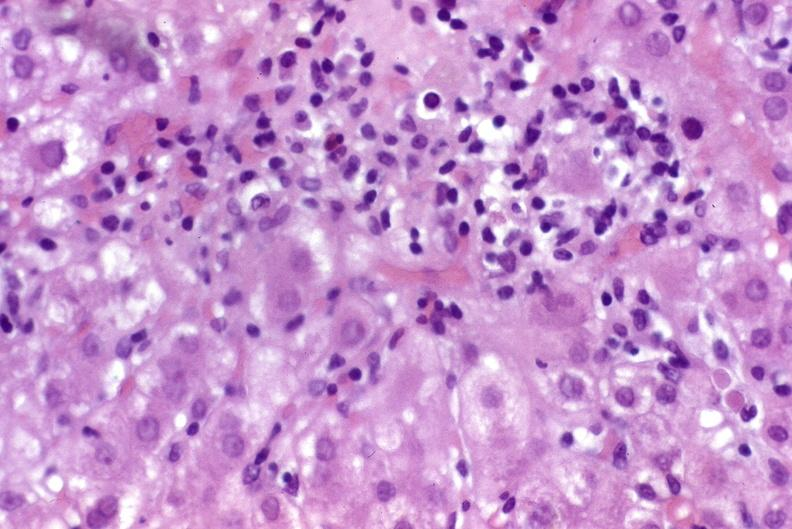what is present?
Answer the question using a single word or phrase. Liver 